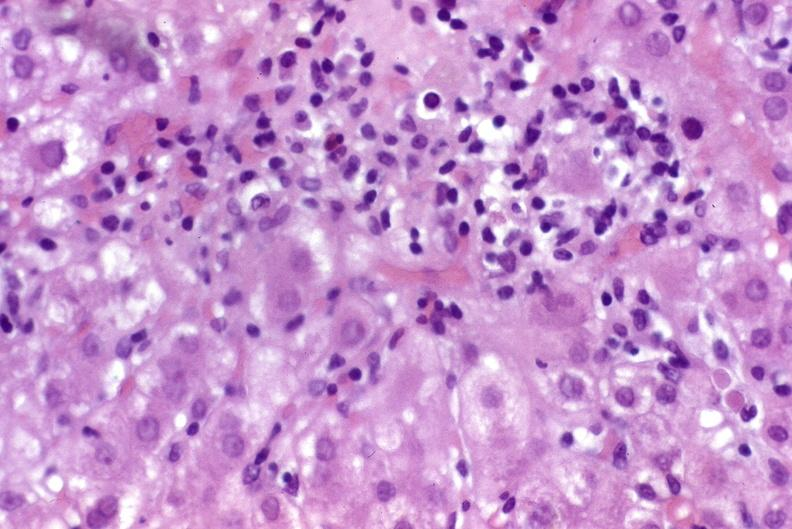what is present?
Answer the question using a single word or phrase. Liver 